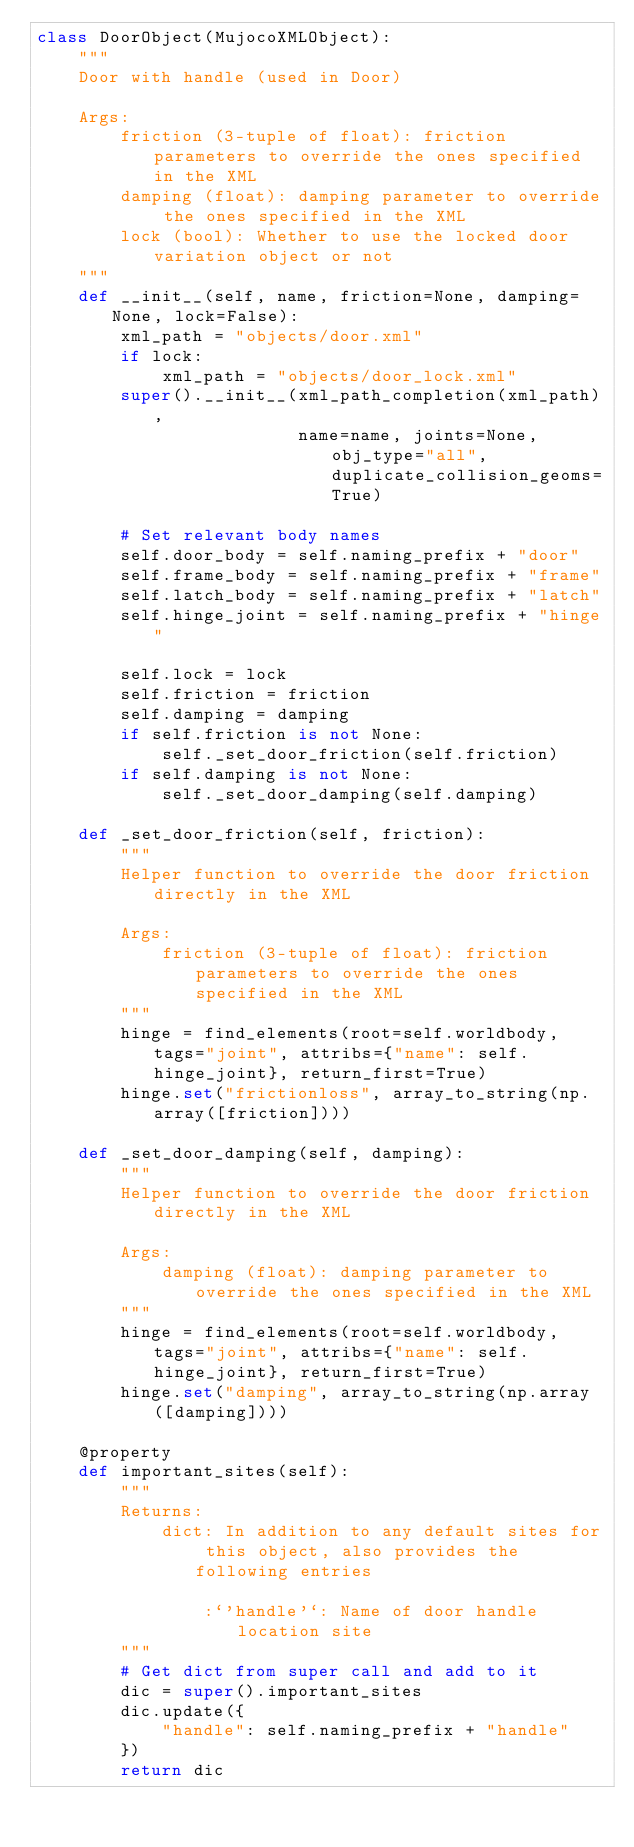<code> <loc_0><loc_0><loc_500><loc_500><_Python_>class DoorObject(MujocoXMLObject):
    """
    Door with handle (used in Door)

    Args:
        friction (3-tuple of float): friction parameters to override the ones specified in the XML
        damping (float): damping parameter to override the ones specified in the XML
        lock (bool): Whether to use the locked door variation object or not
    """
    def __init__(self, name, friction=None, damping=None, lock=False):
        xml_path = "objects/door.xml"
        if lock:
            xml_path = "objects/door_lock.xml"
        super().__init__(xml_path_completion(xml_path),
                         name=name, joints=None, obj_type="all", duplicate_collision_geoms=True)

        # Set relevant body names
        self.door_body = self.naming_prefix + "door"
        self.frame_body = self.naming_prefix + "frame"
        self.latch_body = self.naming_prefix + "latch"
        self.hinge_joint = self.naming_prefix + "hinge"

        self.lock = lock
        self.friction = friction
        self.damping = damping
        if self.friction is not None:
            self._set_door_friction(self.friction)
        if self.damping is not None:
            self._set_door_damping(self.damping)

    def _set_door_friction(self, friction):
        """
        Helper function to override the door friction directly in the XML

        Args:
            friction (3-tuple of float): friction parameters to override the ones specified in the XML
        """
        hinge = find_elements(root=self.worldbody, tags="joint", attribs={"name": self.hinge_joint}, return_first=True)
        hinge.set("frictionloss", array_to_string(np.array([friction])))

    def _set_door_damping(self, damping):
        """
        Helper function to override the door friction directly in the XML

        Args:
            damping (float): damping parameter to override the ones specified in the XML
        """
        hinge = find_elements(root=self.worldbody, tags="joint", attribs={"name": self.hinge_joint}, return_first=True)
        hinge.set("damping", array_to_string(np.array([damping])))

    @property
    def important_sites(self):
        """
        Returns:
            dict: In addition to any default sites for this object, also provides the following entries

                :`'handle'`: Name of door handle location site
        """
        # Get dict from super call and add to it
        dic = super().important_sites
        dic.update({
            "handle": self.naming_prefix + "handle"
        })
        return dic
</code> 